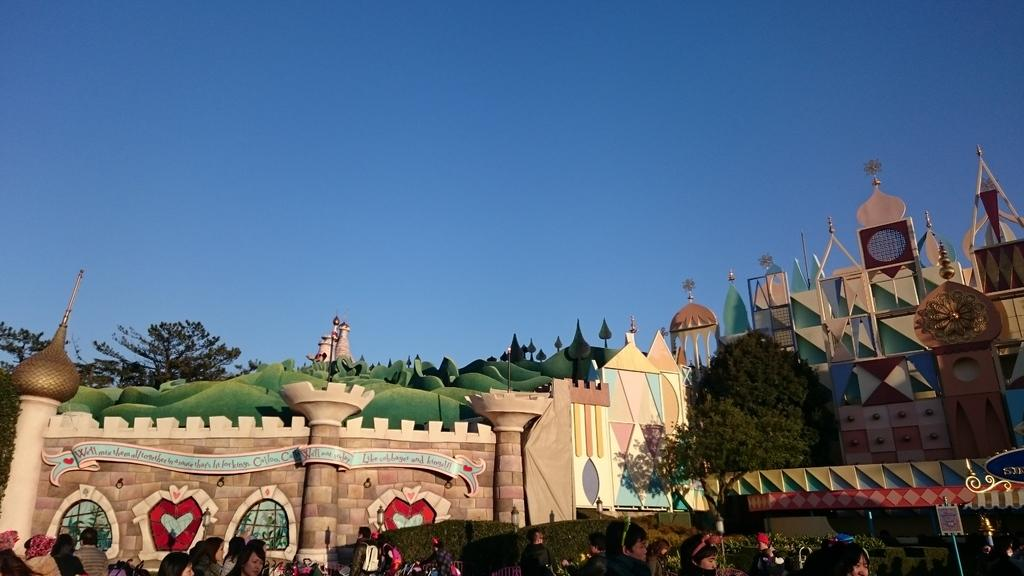What type of structure is in the image? There is a castle in the image. What other elements can be seen in the image? There are trees, people, and a name board in the image. What is visible in the background of the image? The sky is visible in the background of the image. What type of pet is being carried by one of the people in the image? There is no pet visible in the image; only people, a castle, trees, a name board, and the sky are present. 